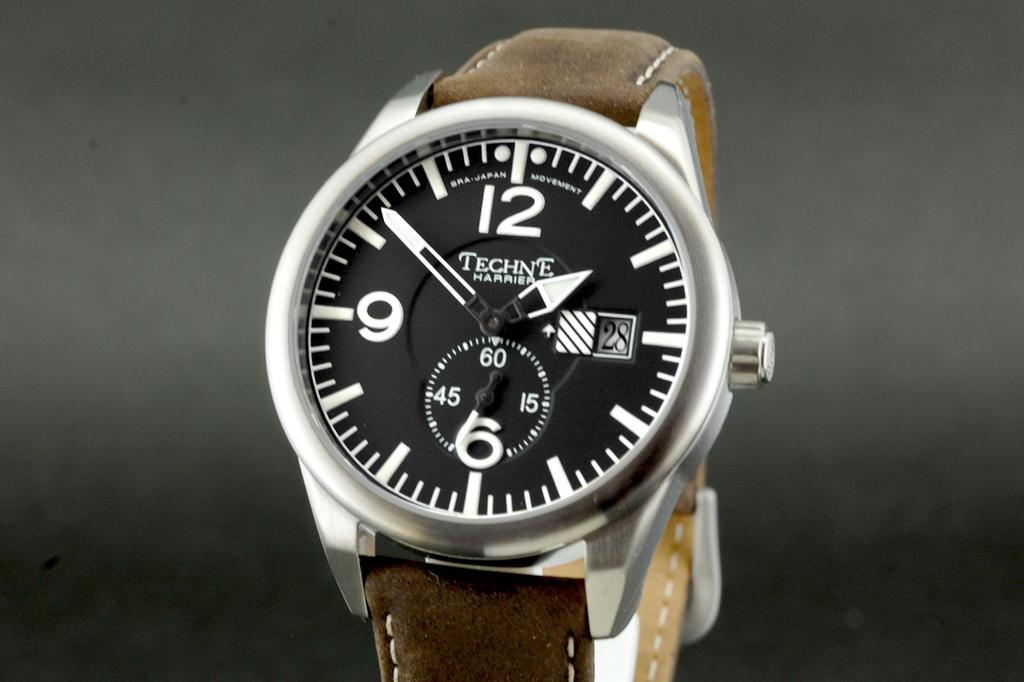What is the brand of the watch?
Your answer should be compact. Techne. 